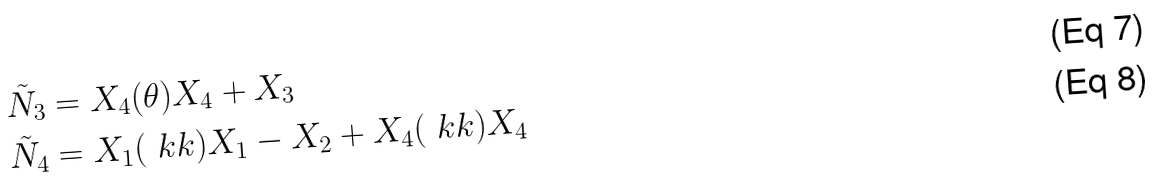<formula> <loc_0><loc_0><loc_500><loc_500>\tilde { N } _ { 3 } & = X _ { 4 } ( \theta ) X _ { 4 } + X _ { 3 } \\ \tilde { N } _ { 4 } & = X _ { 1 } ( \ k k ) X _ { 1 } - X _ { 2 } + X _ { 4 } ( \ k k ) X _ { 4 }</formula> 